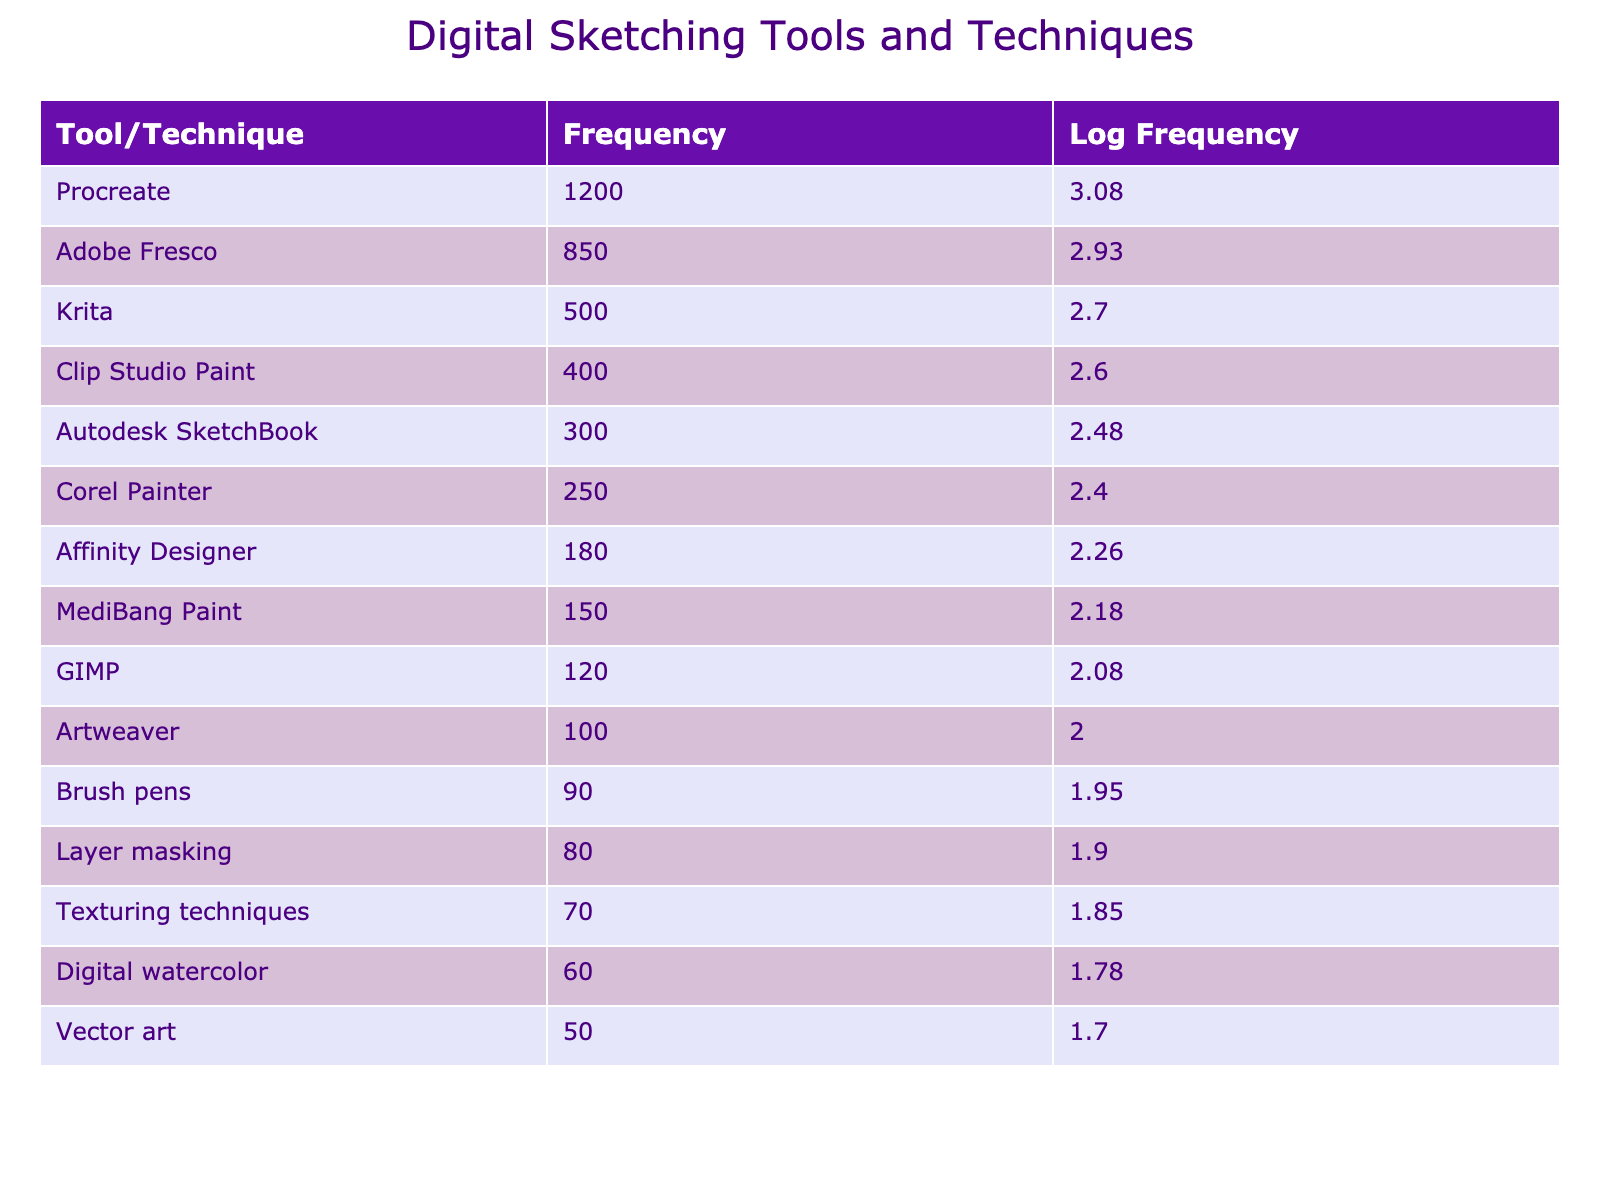What is the most frequently mentioned digital sketching tool? The table lists the frequency of various tools and techniques. The tool with the highest frequency is Procreate, which has a frequency of 1200.
Answer: Procreate Is the frequency of Adobe Fresco greater than Krita? Adobe Fresco has a frequency of 850, while Krita has a frequency of 500. Since 850 is greater than 500, the statement is true.
Answer: Yes What is the total frequency of the three most mentioned tools? The three most mentioned tools are Procreate (1200), Adobe Fresco (850), and Krita (500). Their total frequency is calculated by adding these three values: 1200 + 850 + 500 = 2550.
Answer: 2550 What is the difference in frequency between Corel Painter and GIMP? Corel Painter has a frequency of 250, while GIMP has a frequency of 120. To find the difference, subtract GIMP's frequency from Corel Painter's frequency: 250 - 120 = 130.
Answer: 130 Is the frequency for Layer masking more than double that of Texturing techniques? Layer masking has a frequency of 80, and Texturing techniques have a frequency of 70. Double the frequency of Texturing techniques is 70 * 2 = 140, which is more than 80. Thus, Layer masking is not more than double that of Texturing techniques.
Answer: No What is the average frequency of the tools and techniques listed? To find the average frequency, first sum the frequencies of all the tools and techniques and then divide by the total number of entries (15). The sum is 1200 + 850 + 500 + 400 + 300 + 250 + 180 + 150 + 120 + 100 + 90 + 80 + 70 + 60 + 50 = 3120. Now, divide 3120 by 15 to get the average: 3120 / 15 = 208.
Answer: 208 How many techniques listed have a frequency below 100? Looking at the table, the only two techniques with a frequency below 100 are Brush pens (90) and Artweaver (100). Since Artweaver is exactly 100, it does not count as below. Thus, only Brush pens qualify.
Answer: 1 What is the Log Frequency of Clip Studio Paint? The frequency of Clip Studio Paint is 400. The logarithmic value is calculated as the logarithm base 10 of 400, which is approximately 2.60 when rounded to two decimal places.
Answer: 2.60 Which tool has a Log Frequency closest to Affinity Designer? Affinity Designer has a Log Frequency of approximately 2.25. The nearest tool with a similar Log Frequency is Autodesk SketchBook, which has a frequency of 300. Its Log Frequency is calculated as approximately 2.48. 2.25 and 2.48 are relatively close.
Answer: Autodesk SketchBook 